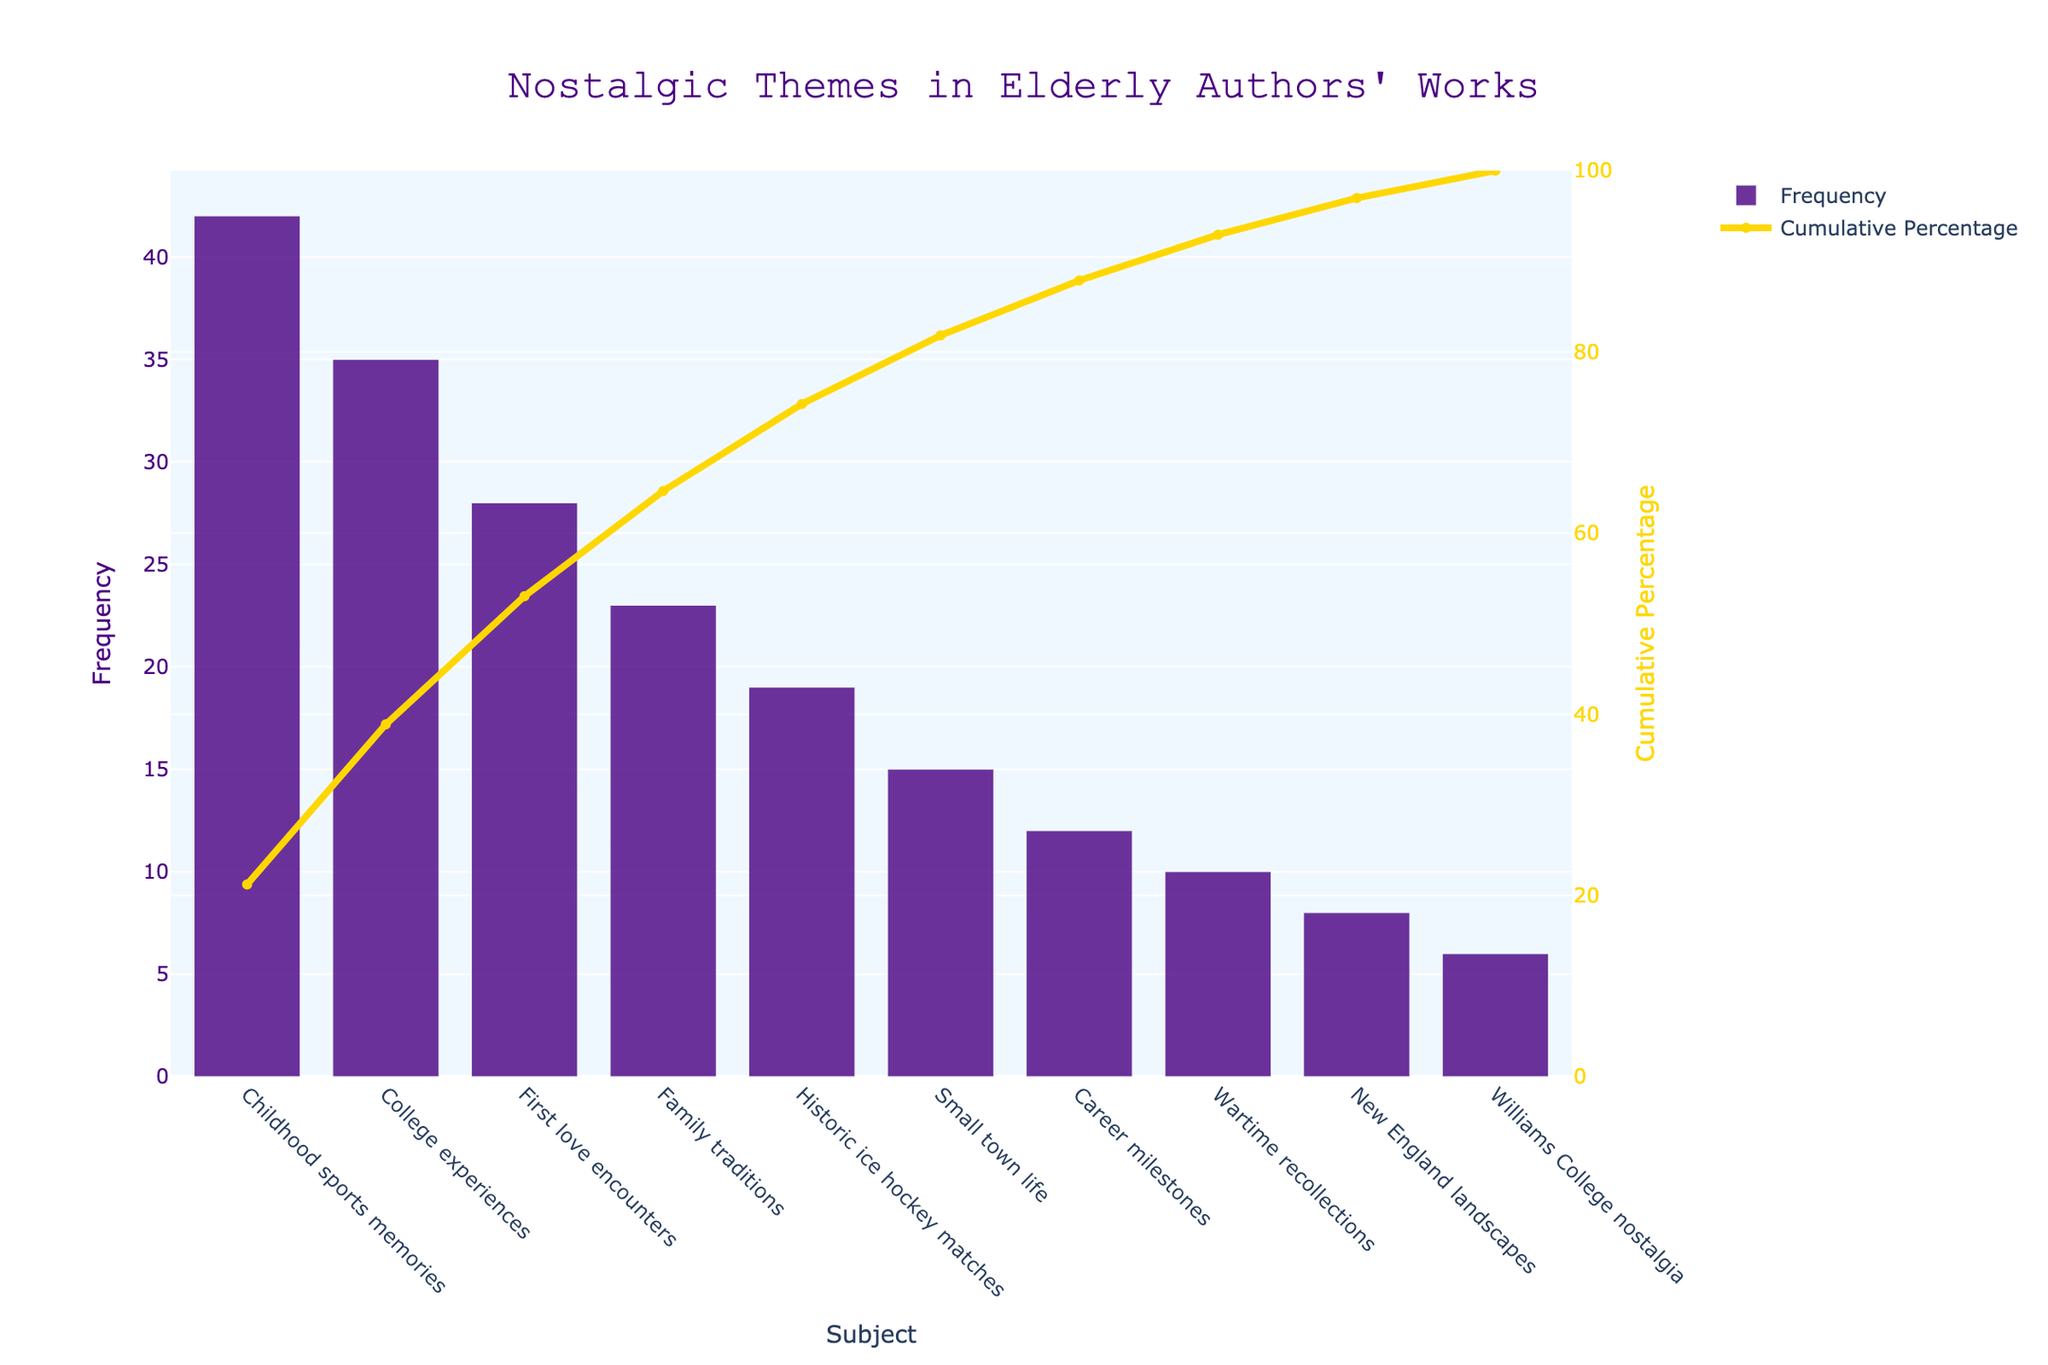What's the most frequent nostalgic theme in the works of elderly authors? The most frequent nostalgic theme can be identified by looking at the highest bar in the Pareto chart. The tallest bar represents "Childhood sports memories" with a frequency of 42.
Answer: Childhood sports memories What's the cumulative percentage achieved by the top three themes? To find the cumulative percentage for the top three themes, sum the frequencies of "Childhood sports memories" (42), "College experiences" (35), and "First love encounters" (28), then divide by the total frequency sum, and multiply by 100. Frequency sum = 42+35+28 = 105. Total frequency = 198. Cumulative percentage = (105/198) * 100 ≈ 53%.
Answer: 53% Which nostalgic theme has a similar frequency to "Historic ice hockey matches"? To find a theme with a similar frequency to "Historic ice hockey matches" which has a frequency of 19, compare it to other bars. "Family traditions" has a frequency of 23, close to 19.
Answer: Family traditions What is the least frequent theme depicted on the chart? The least frequent theme can be identified by looking at the shortest bar in the Pareto chart. The shortest bar represents "Williams College nostalgia" with a frequency of 6.
Answer: Williams College nostalgia By what percentage does “Childhood sports memories” exceed “First love encounters”? Subtract the frequency of "First love encounters" (28) from "Childhood sports memories" (42), then divide by the frequency of "First love encounters", and multiply by 100. Difference = 42 - 28 = 14. Percentage = (14/28) * 100 = 50%.
Answer: 50% What cumulative percentage is achieved by adding "Wartime recollections" to the previous themes up to "Small town life"? Add the frequencies of themes up to "Small town life", including "Wartime recollections": 42 (Childhood sports memories) + 35 (College experiences) + 28 (First love encounters) + 23 (Family traditions) + 19 (Historic ice hockey matches) + 15 (Small town life) + 10 (Wartime recollections) = 172. Total frequency = 198. Cumulative percentage = (172/198) * 100 ≈ 87%.
Answer: 87% Compare the frequency of "Small town life" to "Career milestones" and state the higher one. Compare the heights of the bars for "Small town life" (15) and "Career milestones" (12). "Small town life" has a higher frequency.
Answer: Small town life At what cumulative percentage does the frequency of themes reach over 75%? Identify the cumulative percentage threshold that surpasses 75%. Cumulative frequency calculation: Childhood sports memories (21.21%), College experiences (39.39%), First love encounters (53.54%), Family traditions (65.66%), Historic ice hockey matches (75.76%), Small town life (83.84%). At "Small town life", the cumulative percentage surpasses 75%, reaching approximately 83.84%.
Answer: Small town life What is the cumulative frequency up to "Family traditions"? To find the cumulative frequency up to "Family traditions", add the frequencies of the themes leading up to and including "Family traditions": 42 + 35 + 28 + 23 = 128.
Answer: 128 